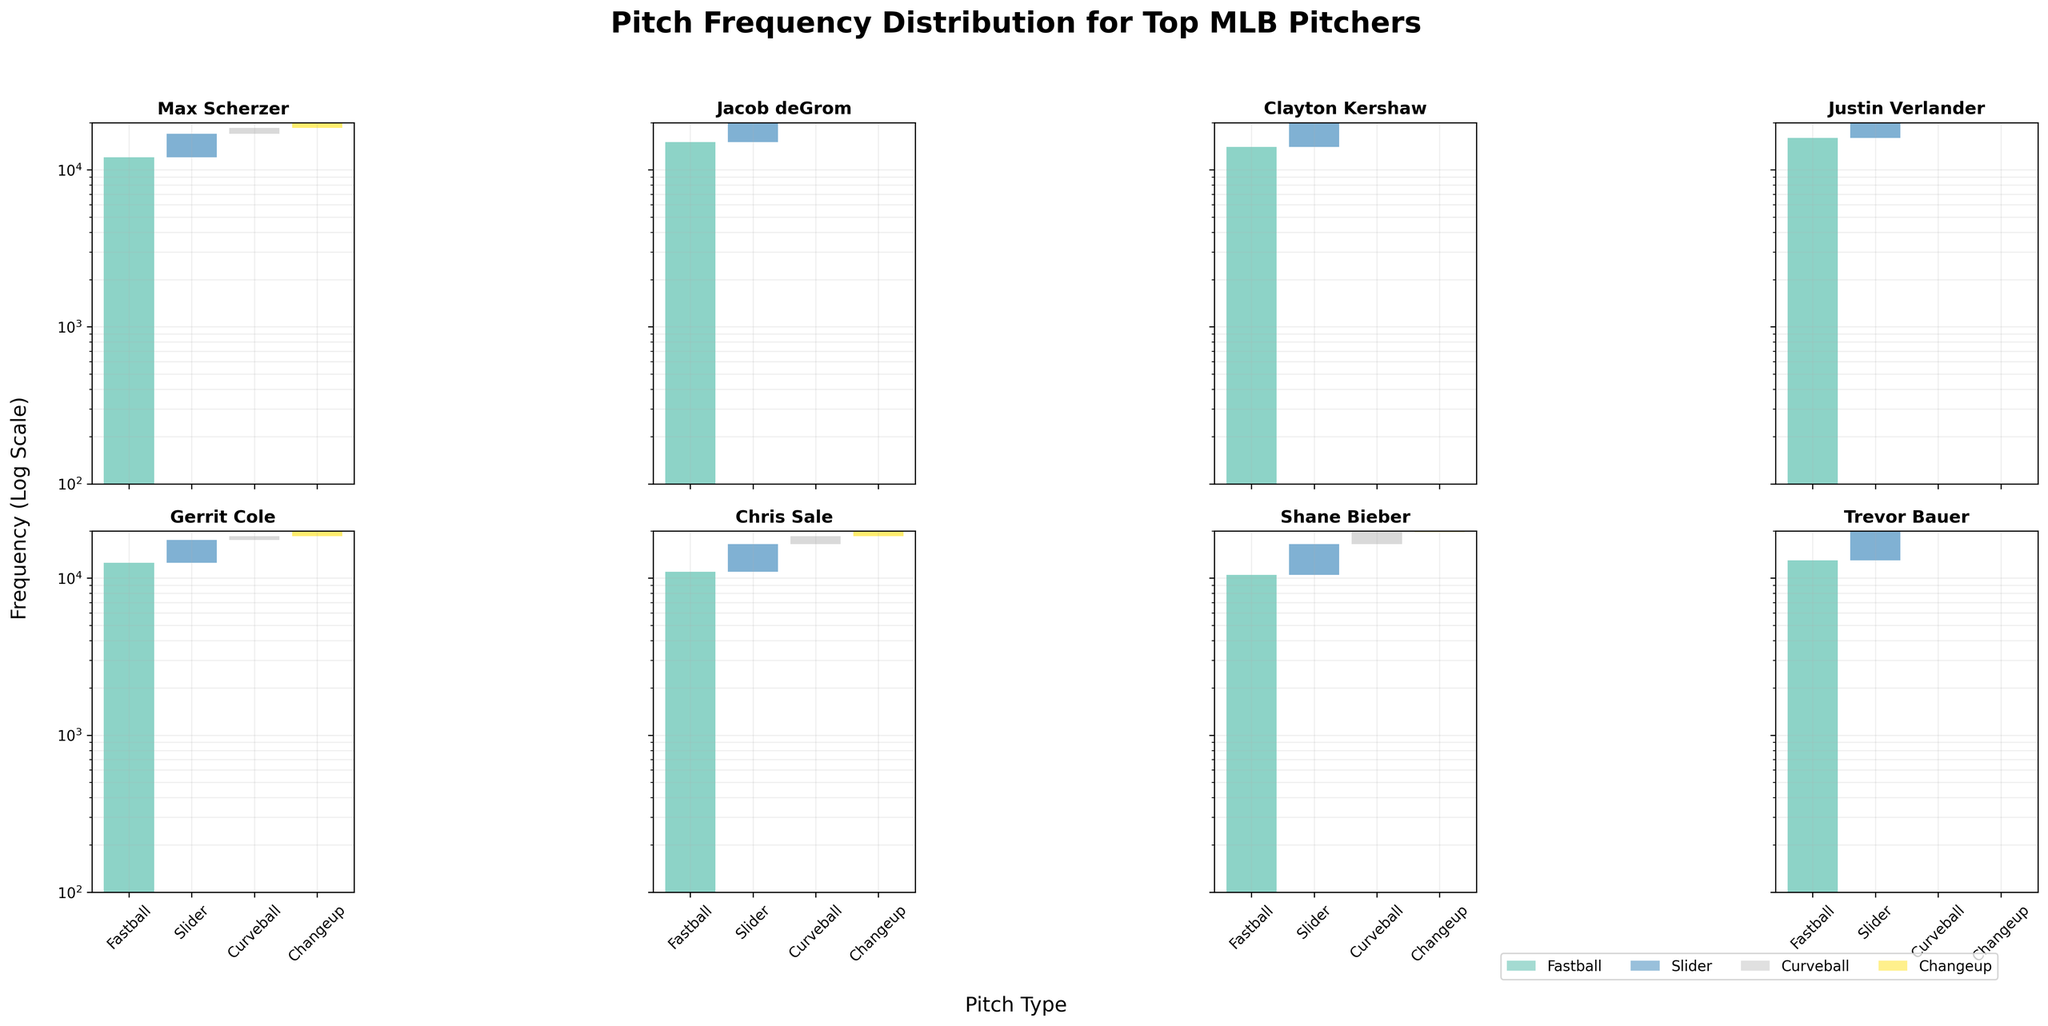What's the title of the plot? The title is displayed at the top-center of the plot.
Answer: Pitch Frequency Distribution for Top MLB Pitchers What is the frequency range shown on the y-axis? The y-axis uses a log scale, and it is labeled with values ranging from 100 to 20,000.
Answer: 100 to 20,000 Which pitcher throws Curveball the most frequently? By looking at the height of the Curveball bars, Clayton Kershaw has the tallest Curveball bar.
Answer: Clayton Kershaw How many pitch types are shown in the plot? Each subplot shows four color-coded bars representing different pitch types.
Answer: Four Which pitcher has the highest frequency of Changeup? Comparing the Changeup bars across all subplots, Max Scherzer has the highest frequency.
Answer: Max Scherzer How does Max Scherzer's Slider frequency compare to Justin Verlander's Slider frequency? The height of the Slider bars for both pitchers shows that Justin Verlander's Slider frequency is higher than Max Scherzer's.
Answer: Verlander's frequency is higher What's the sum of the frequencies for Fastballs thrown by Jacob deGrom and Chris Sale? Jacob deGrom's Fastball frequency (15,000) plus Chris Sale's Fastball frequency (11,000) equals 26,000.
Answer: 26,000 Which pitcher throws the least number of Curveballs? By checking the smallest Curveball bars, Gerrit Cole throws the least number of Curveballs.
Answer: Gerrit Cole For Clayton Kershaw, which pitch type has the second-highest frequency? The bars representing the four pitch types for Clayton Kershaw show that his Slider frequency is second-highest after the Fastball.
Answer: Slider 